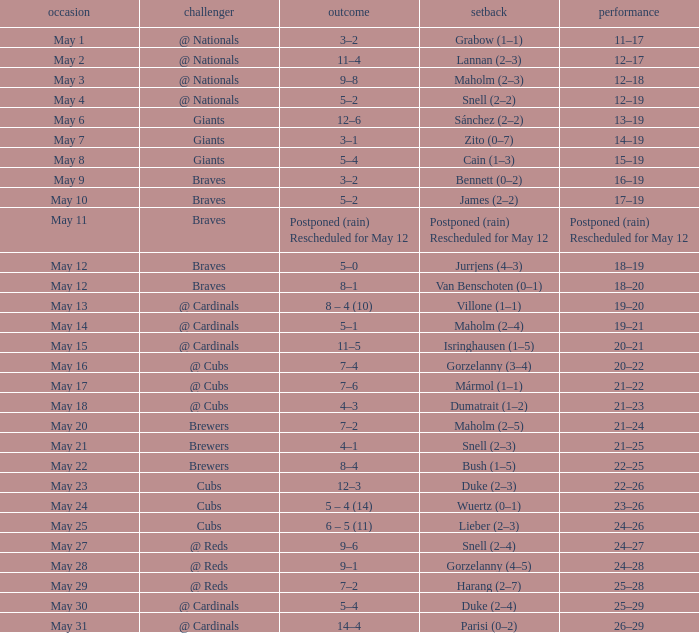What was the date of the game with a loss of Bush (1–5)? May 22. 